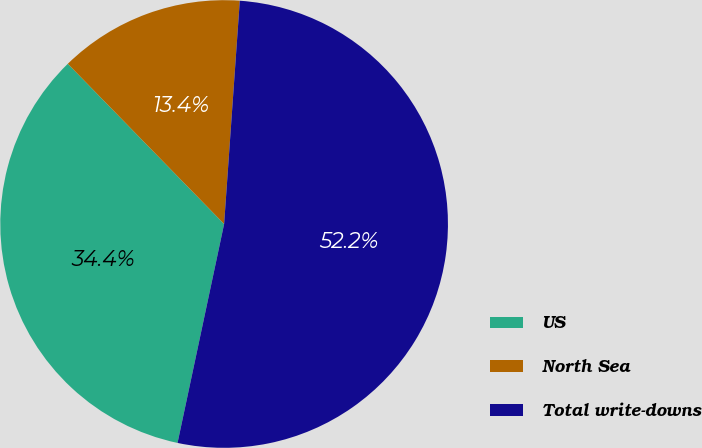<chart> <loc_0><loc_0><loc_500><loc_500><pie_chart><fcel>US<fcel>North Sea<fcel>Total write-downs<nl><fcel>34.36%<fcel>13.42%<fcel>52.22%<nl></chart> 